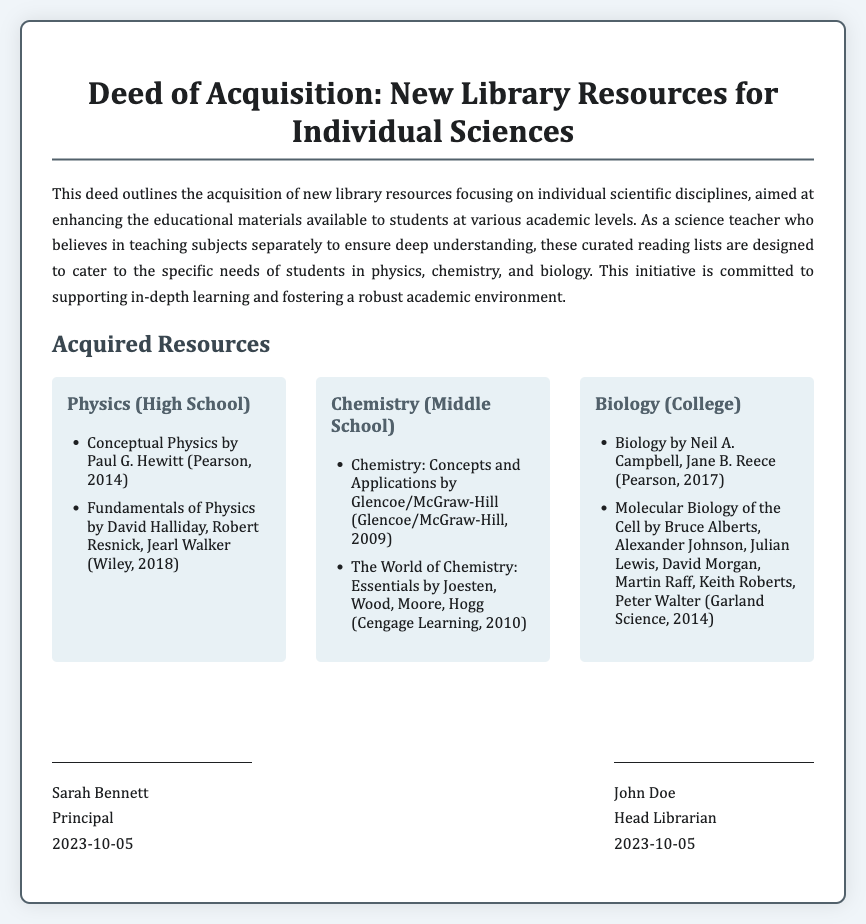What is the title of the document? The title is the main heading found at the top of the document.
Answer: Deed of Acquisition: New Library Resources for Individual Sciences Who is the author of the document? The author is identified by their title and name, as listed at the end of the document.
Answer: Sarah Bennett What is the date of signing? The signing date is mentioned below each signature in the document.
Answer: 2023-10-05 Which subject has resources specifically for high school? The subject specific for high school is listed in the section detailing acquired resources.
Answer: Physics What type of resources does the deed focus on? The focus is indicated in the introductory paragraph describing the purpose of the deed.
Answer: Library resources How many books are listed under Chemistry (Middle School)? The number of items listed under each subject can be counted from the resource section.
Answer: 2 Which publisher produced "Biology"? The publisher information follows the book title in the resource list for Biology.
Answer: Pearson What is the educational level targeted by the biology resources? The educational level is stated clearly in the heading for the biology section.
Answer: College What is the purpose of the deed? The purpose can be inferred from the introductory text that describes its intent and goals.
Answer: Enhancing educational materials 